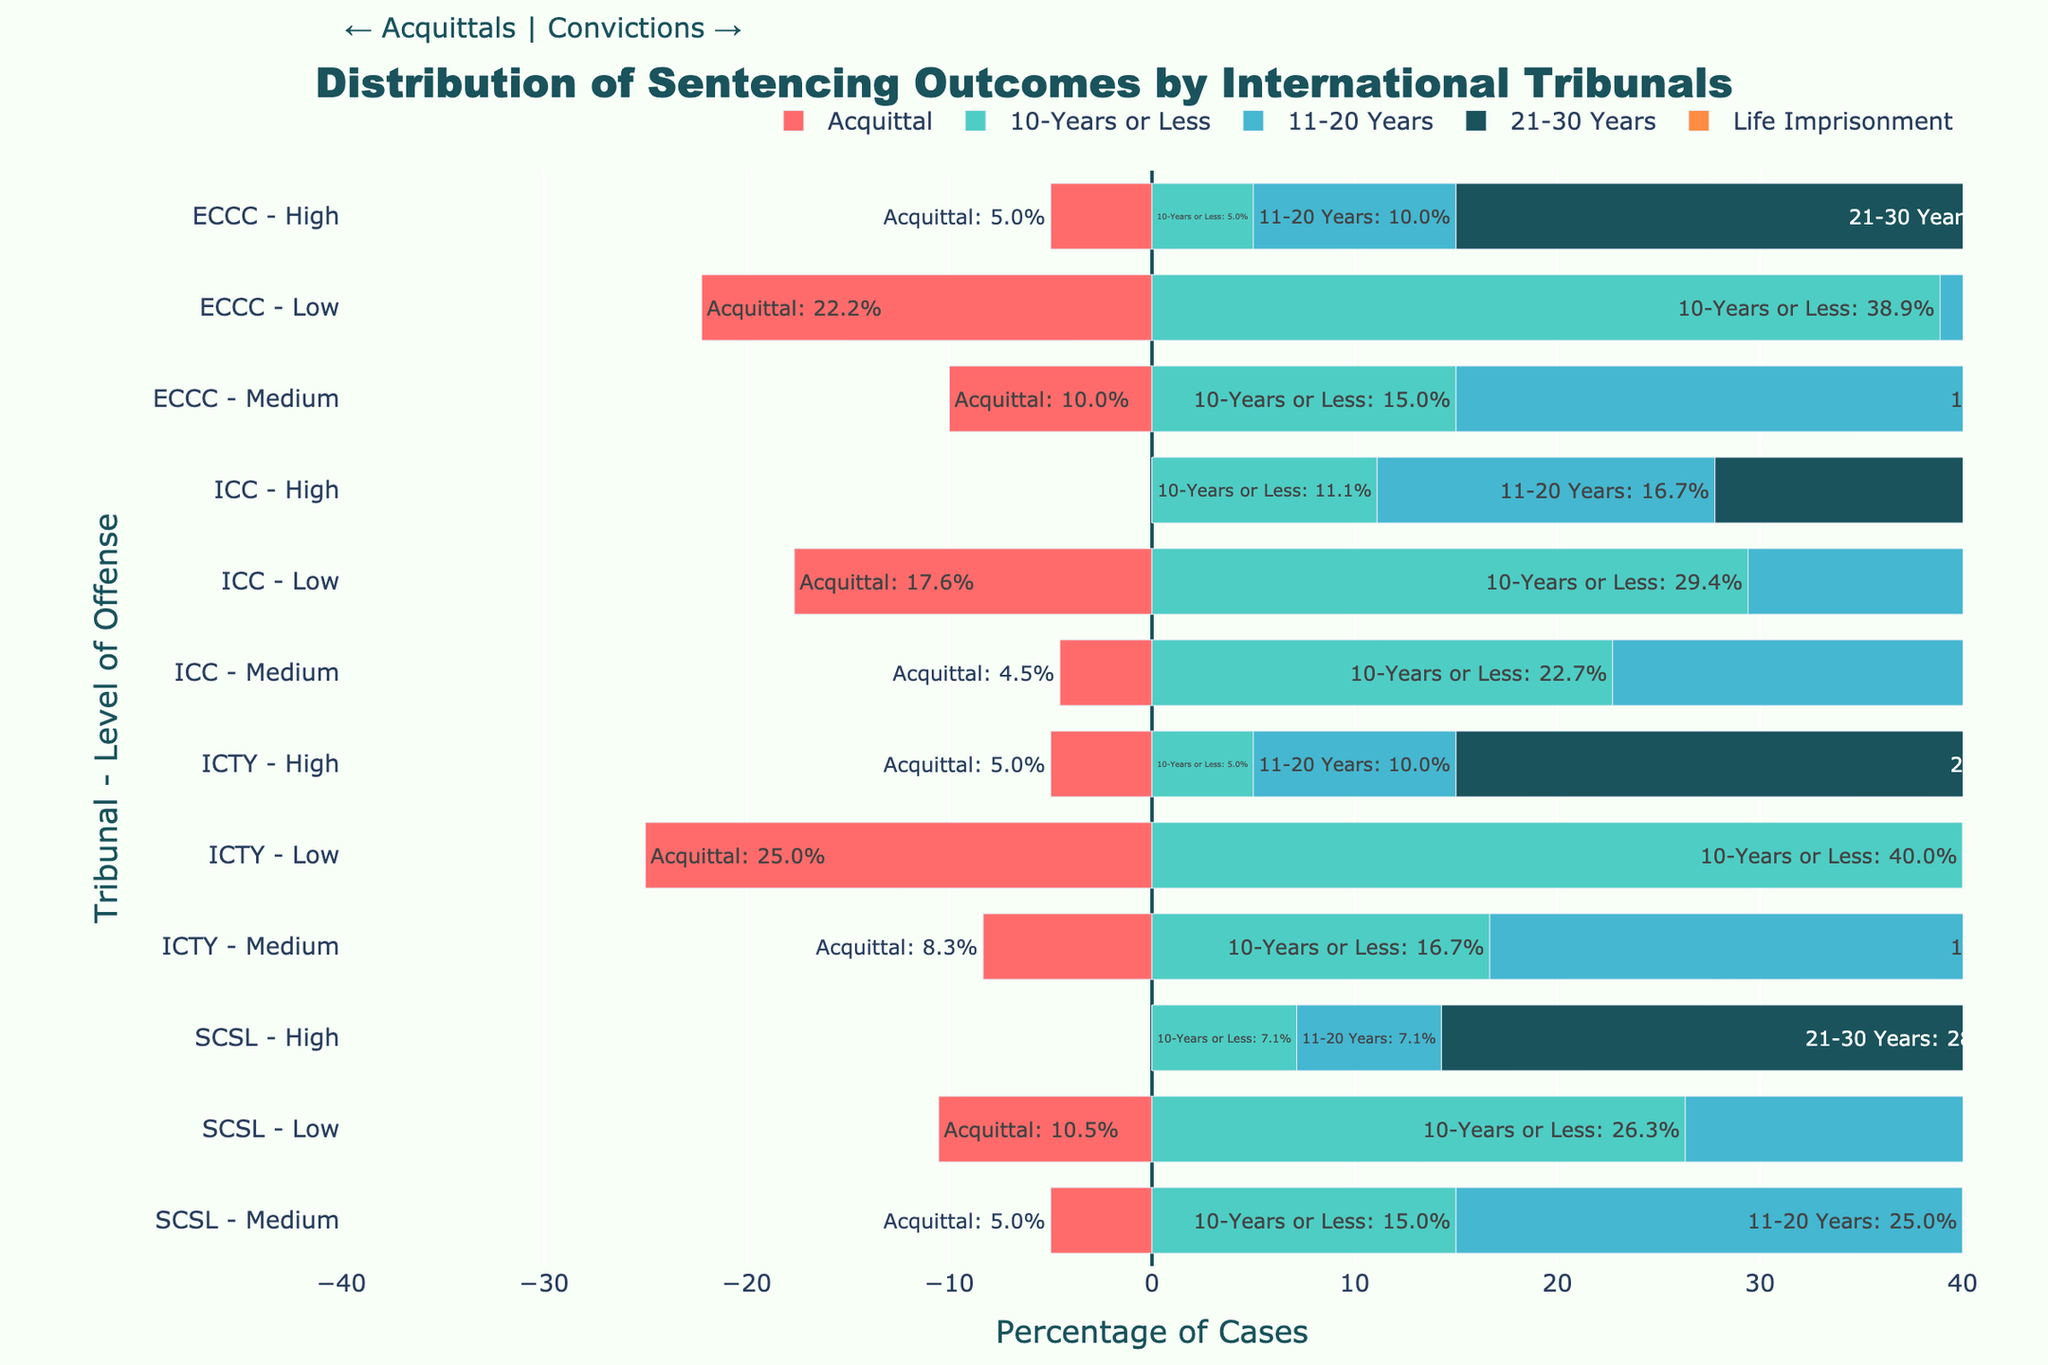What is the percentage of acquittals for the ICTY tribunal at the low level of offense? The bar representing acquittals for ICTY at the low level is to the left, indicating a percentage. Based on the hover text, it is 20.0%.
Answer: 20.0% Do the ICTY and ICC tribunals show a higher percentage of life imprisonment sentences for high-level offenses? Comparing the lengths of the bars for life imprisonment sentences, the lengths for ICTY and ICC at high-level offenses are similar. Both have significant percentages of life imprisonment. Hover text shows ICTY has 40.9% and ICC has 38.1%.
Answer: Yes Which tribunal has the highest percentage of acquittals for medium level offenses? By comparing the lengths of the acquittal bars for medium-level offenses across tribunals, ICTY, ICC, and ECCC show acquittals for medium level. Hover text indicates ICTY has the highest with 10.0%.
Answer: ICTY What is the percentage difference between acquittals and life imprisonment for high-level offenses in the SCSL tribunal? For SCSL high-level offenses, the percentage for acquittals is 0% (no bar present) and for life imprisonment is 57.1%. The difference is 57.1% - 0%.
Answer: 57.1% How do the percentages of sentences of 21-30 years for medium-level offenses compare between the ICTY and ECCC tribunals? Comparing the bars for 21-30 years at medium-level offenses, ICTY and ECCC show noticeable bars. Hover text shows ICTY has 30.0% and ECCC has 29.4%, indicating they are very close.
Answer: ICTY is slightly higher Which tribunal and offense level combination shows the highest percentage of life imprisonment sentences? Looking at the length of the bars for life imprisonment across all combinations, the high-level offense in ECCC shows the longest bar. Hover text confirms it's 47.6%.
Answer: ECCC high level Are acquittals more common for low-level or medium-level offenses in the ICC tribunal? Comparing the lengths of the acquittal bars for ICC in low and medium levels, the low level has a longer bar. Hover text indicates low level is 17.6% and medium level is 5.3%.
Answer: Low level What is the combined percentage of sentences of 11-20 years and 21-30 years for low-level offenses in ICTY? For ICTY low level, the hover text shows 11-20 years at 19.0% and 21-30 years at 4.8%. Adding these gives 19.0% + 4.8% = 23.8%.
Answer: 23.8% Does the ECCC tribunal have a higher percentage of 10-years or less sentences for low or medium-level offenses? Comparing the bars for 10-years or less in ECCC for low and medium levels, the low level has a longer bar. Hover text indicates low level is 41.2% and medium level is 17.6%.
Answer: Low level Between the ICTY and SCSL tribunals, which has a higher percentage of life imprisonment sentences for medium-level offenses? The bars for life imprisonment at medium-level offenses show SCSL has a slightly longer bar. Hover text indicates ICTY has 20.0% and SCSL has 17.6%.
Answer: ICTY 